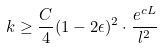Convert formula to latex. <formula><loc_0><loc_0><loc_500><loc_500>k \geq \frac { C } { 4 } ( 1 - 2 \epsilon ) ^ { 2 } \cdot \frac { e ^ { c L } } { l ^ { 2 } }</formula> 